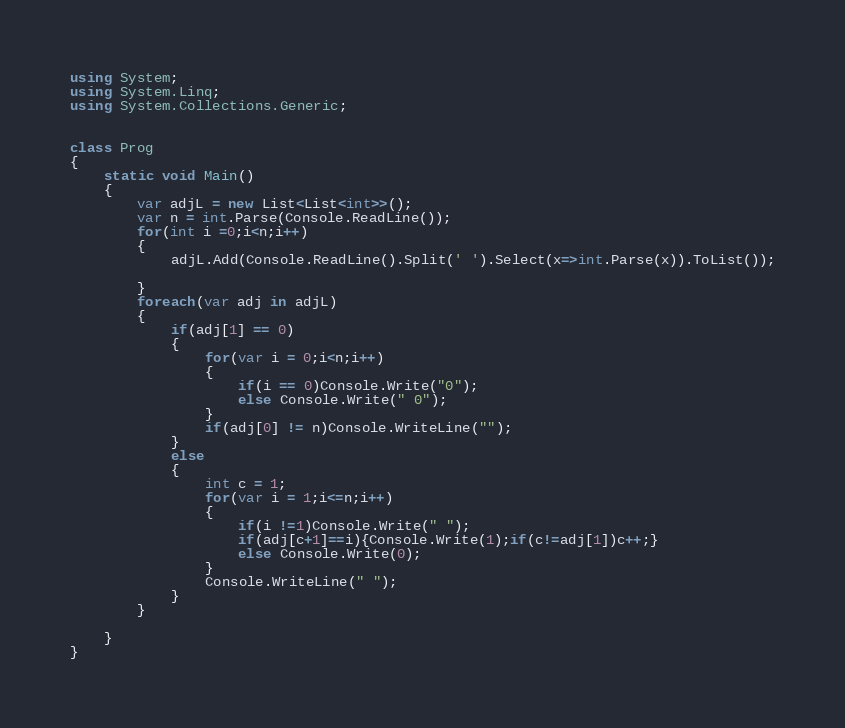Convert code to text. <code><loc_0><loc_0><loc_500><loc_500><_C#_>using System;
using System.Linq;
using System.Collections.Generic;


class Prog
{
	static void Main()
	{
		var adjL = new List<List<int>>();
		var n = int.Parse(Console.ReadLine());
		for(int i =0;i<n;i++)
		{
			adjL.Add(Console.ReadLine().Split(' ').Select(x=>int.Parse(x)).ToList());

		}
		foreach(var adj in adjL)
		{
			if(adj[1] == 0)
			{
				for(var i = 0;i<n;i++)
				{
					if(i == 0)Console.Write("0");
					else Console.Write(" 0");
				}
				if(adj[0] != n)Console.WriteLine("");
			}
			else
			{
				int c = 1;
				for(var i = 1;i<=n;i++)
				{
					if(i !=1)Console.Write(" ");
					if(adj[c+1]==i){Console.Write(1);if(c!=adj[1])c++;}
					else Console.Write(0);
				}
				Console.WriteLine(" ");
			}
		}

	}
}</code> 